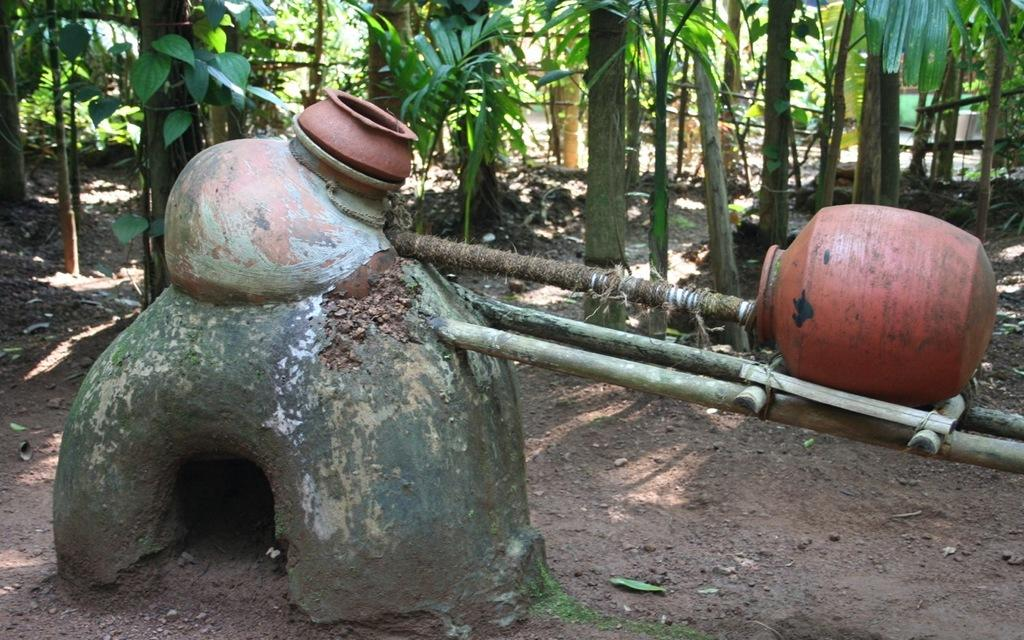What type of objects can be seen in the image? There are pots and sticks in the image. What other natural elements are present in the image? There are trees in the image. What color are the leaves on the trees in the image? The leaves in the image are green. What action is the middle leaf regretting in the image? There is no indication of regret or any action involving leaves in the image. 